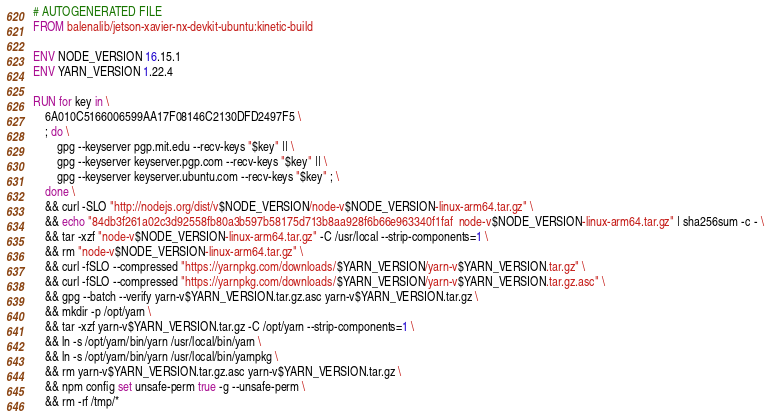Convert code to text. <code><loc_0><loc_0><loc_500><loc_500><_Dockerfile_># AUTOGENERATED FILE
FROM balenalib/jetson-xavier-nx-devkit-ubuntu:kinetic-build

ENV NODE_VERSION 16.15.1
ENV YARN_VERSION 1.22.4

RUN for key in \
	6A010C5166006599AA17F08146C2130DFD2497F5 \
	; do \
		gpg --keyserver pgp.mit.edu --recv-keys "$key" || \
		gpg --keyserver keyserver.pgp.com --recv-keys "$key" || \
		gpg --keyserver keyserver.ubuntu.com --recv-keys "$key" ; \
	done \
	&& curl -SLO "http://nodejs.org/dist/v$NODE_VERSION/node-v$NODE_VERSION-linux-arm64.tar.gz" \
	&& echo "84db3f261a02c3d92558fb80a3b597b58175d713b8aa928f6b66e963340f1faf  node-v$NODE_VERSION-linux-arm64.tar.gz" | sha256sum -c - \
	&& tar -xzf "node-v$NODE_VERSION-linux-arm64.tar.gz" -C /usr/local --strip-components=1 \
	&& rm "node-v$NODE_VERSION-linux-arm64.tar.gz" \
	&& curl -fSLO --compressed "https://yarnpkg.com/downloads/$YARN_VERSION/yarn-v$YARN_VERSION.tar.gz" \
	&& curl -fSLO --compressed "https://yarnpkg.com/downloads/$YARN_VERSION/yarn-v$YARN_VERSION.tar.gz.asc" \
	&& gpg --batch --verify yarn-v$YARN_VERSION.tar.gz.asc yarn-v$YARN_VERSION.tar.gz \
	&& mkdir -p /opt/yarn \
	&& tar -xzf yarn-v$YARN_VERSION.tar.gz -C /opt/yarn --strip-components=1 \
	&& ln -s /opt/yarn/bin/yarn /usr/local/bin/yarn \
	&& ln -s /opt/yarn/bin/yarn /usr/local/bin/yarnpkg \
	&& rm yarn-v$YARN_VERSION.tar.gz.asc yarn-v$YARN_VERSION.tar.gz \
	&& npm config set unsafe-perm true -g --unsafe-perm \
	&& rm -rf /tmp/*
</code> 